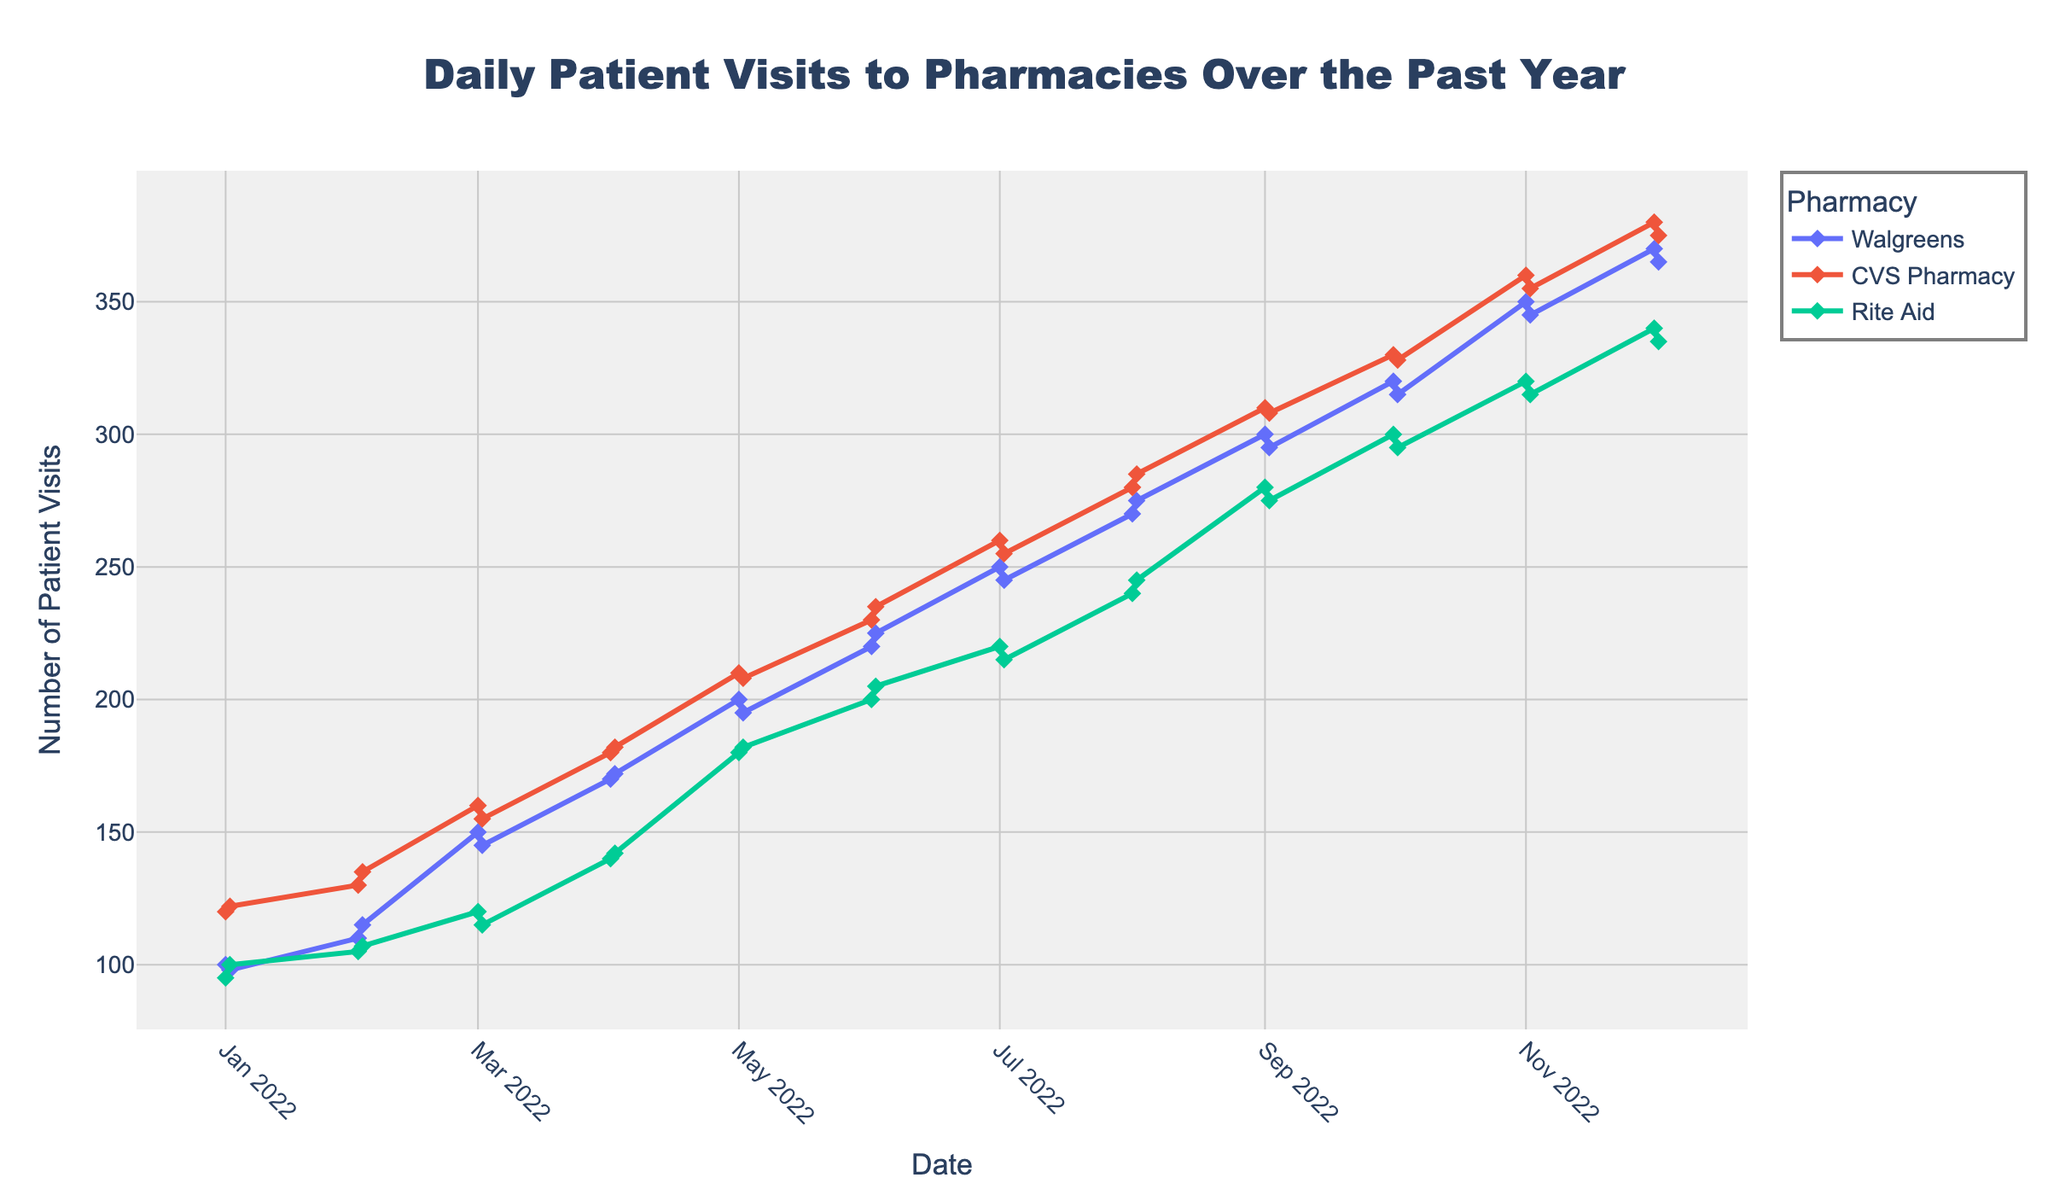What is the title of the figure? The title is usually located at the top of the figure, and it provides a concise summary of what the plot represents. We can find the title in the middle top area of the figure.
Answer: Daily Patient Visits to Pharmacies Over the Past Year How many pharmacies are shown in the figure? The legend on the right-hand side of the figure usually indicates the different categories, which in this case are the pharmacies. By counting the unique entries in the legend, we know how many pharmacies are plotted.
Answer: 3 Which pharmacy had the highest number of patient visits in December 2022? We need to look for the data point corresponding to December 2022 and compare the visit counts for each pharmacy. The highest value among these will be our answer. By observing the data points, we see that CVS Pharmacy had the highest patient visits.
Answer: CVS Pharmacy Which month shows the highest overall visits across all pharmacies? We observe each month's overall trend line peaks and compare them. September 2022 appears to have the highest peaks among all months when summed for all pharmacies.
Answer: September 2022 What is the trend in patient visits for Walgreens from January to December 2022? To analyze the trend, we trace the line specific to Walgreens from left (January) to right (December). We observe a steady increase in the number of patient visits over the months.
Answer: Steady increase How do the visit counts for Rite Aid compare between July and August 2022? We locate the data points for Rite Aid in July and August, then compare their values. July has a lower visit count than August.
Answer: August has higher visits What is the difference in the number of visits between Walgreens and CVS Pharmacy in May 2022? Find the data points for both Walgreens and CVS Pharmacy in May and subtract the visits count of Walgreens from CVS Pharmacy to get the difference.
Answer: 10 How do the visit patterns for CVS Pharmacy and Walgreens differ throughout the year? Tracing both CVS Pharmacy and Walgreens lines from the start (January) to the end (December), we compare their general shapes and trends. While both show an increasing trend, the slope and peaks for CVS Pharmacy are generally higher compared to Walgreens.
Answer: CVS Pharmacy increases at a higher rate In which month did Rite Aid see the smallest number of patient visits? We look for the lowest point on the Rite Aid line throughout the entire plot, which indicates the month with the smallest number of patient visits. This occurs in January 2022.
Answer: January 2022 What is the general trend observed across all three pharmacies over the year? Observing all three lines collectively, we note that all exhibit a generally upward trend from January to December, indicating an overall increase in patient visits.
Answer: Upward trend 